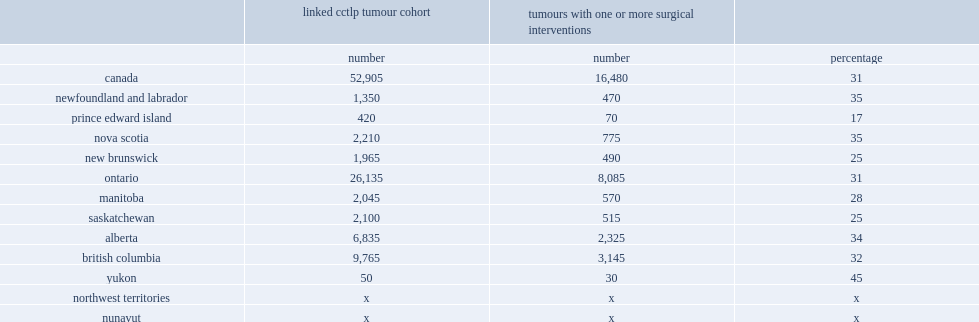What is the percentage of prostate cancer tumours received a surgical intervention? 31.0. List the province or territory where 35% of prostate cancer tumours received a surgical intervention. Newfoundland and labrador nova scotia. 